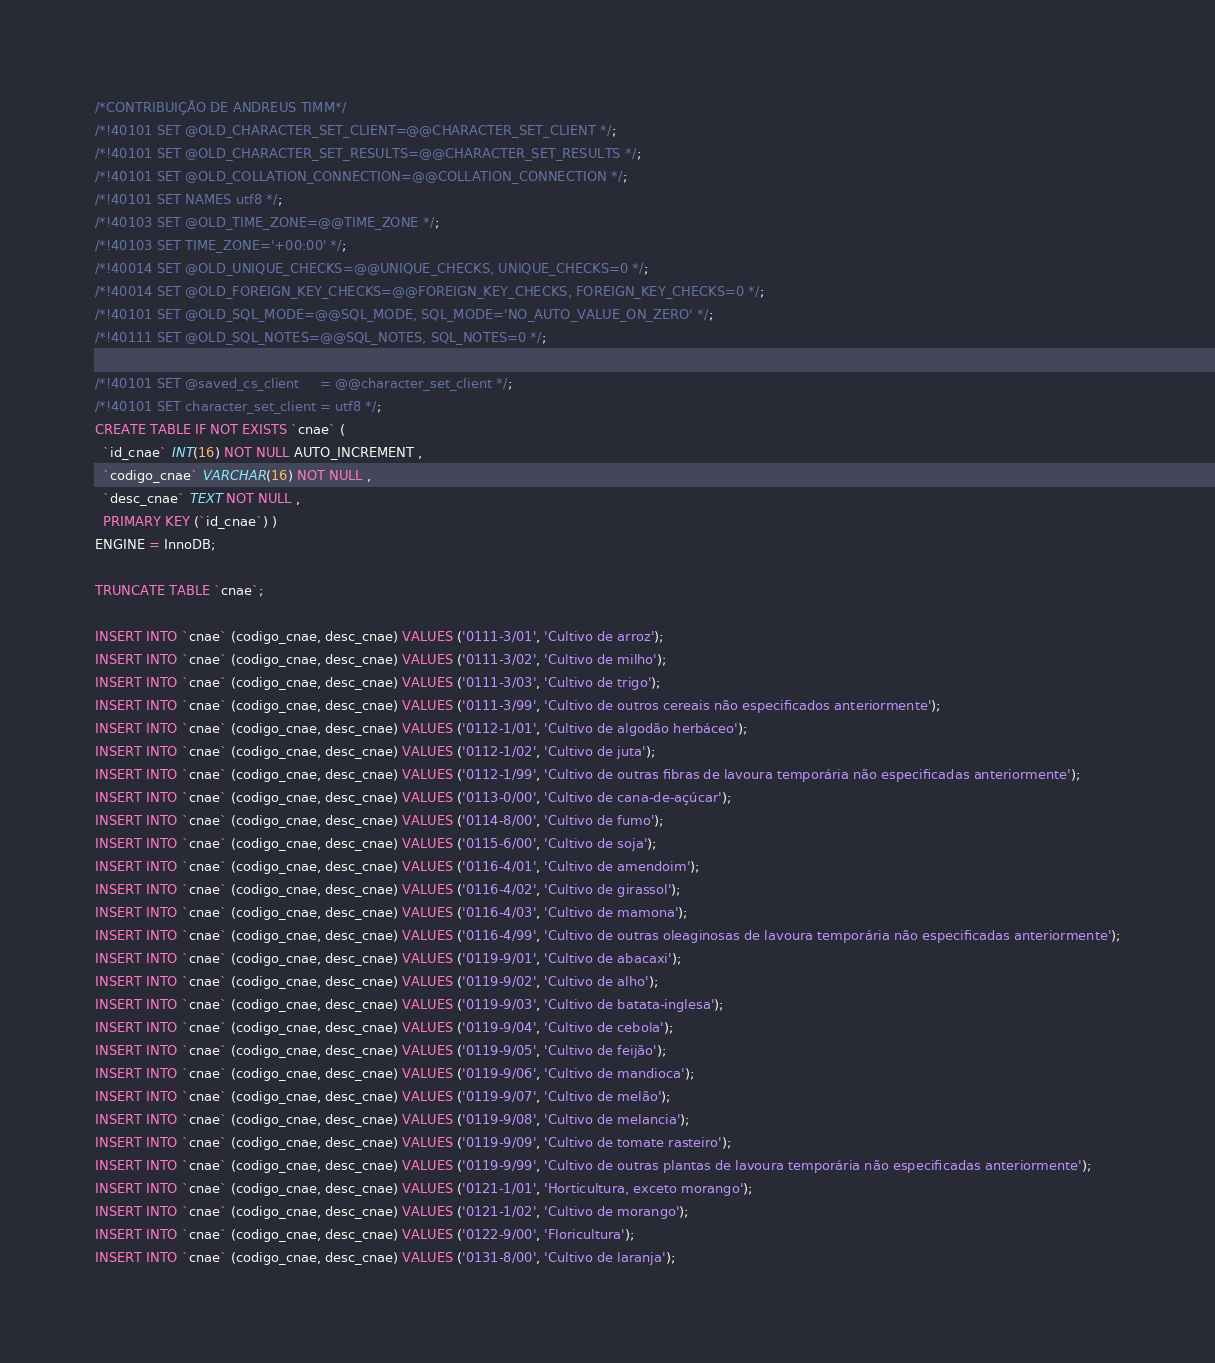Convert code to text. <code><loc_0><loc_0><loc_500><loc_500><_SQL_>/*CONTRIBUIÇÃO DE ANDREUS TIMM*/
/*!40101 SET @OLD_CHARACTER_SET_CLIENT=@@CHARACTER_SET_CLIENT */;
/*!40101 SET @OLD_CHARACTER_SET_RESULTS=@@CHARACTER_SET_RESULTS */;
/*!40101 SET @OLD_COLLATION_CONNECTION=@@COLLATION_CONNECTION */;
/*!40101 SET NAMES utf8 */;
/*!40103 SET @OLD_TIME_ZONE=@@TIME_ZONE */;
/*!40103 SET TIME_ZONE='+00:00' */;
/*!40014 SET @OLD_UNIQUE_CHECKS=@@UNIQUE_CHECKS, UNIQUE_CHECKS=0 */;
/*!40014 SET @OLD_FOREIGN_KEY_CHECKS=@@FOREIGN_KEY_CHECKS, FOREIGN_KEY_CHECKS=0 */;
/*!40101 SET @OLD_SQL_MODE=@@SQL_MODE, SQL_MODE='NO_AUTO_VALUE_ON_ZERO' */;
/*!40111 SET @OLD_SQL_NOTES=@@SQL_NOTES, SQL_NOTES=0 */;

/*!40101 SET @saved_cs_client     = @@character_set_client */;
/*!40101 SET character_set_client = utf8 */;
CREATE TABLE IF NOT EXISTS `cnae` (
  `id_cnae` INT(16) NOT NULL AUTO_INCREMENT ,
  `codigo_cnae` VARCHAR(16) NOT NULL ,
  `desc_cnae` TEXT NOT NULL ,
  PRIMARY KEY (`id_cnae`) )
ENGINE = InnoDB;

TRUNCATE TABLE `cnae`;

INSERT INTO `cnae` (codigo_cnae, desc_cnae) VALUES ('0111-3/01', 'Cultivo de arroz');
INSERT INTO `cnae` (codigo_cnae, desc_cnae) VALUES ('0111-3/02', 'Cultivo de milho');
INSERT INTO `cnae` (codigo_cnae, desc_cnae) VALUES ('0111-3/03', 'Cultivo de trigo');
INSERT INTO `cnae` (codigo_cnae, desc_cnae) VALUES ('0111-3/99', 'Cultivo de outros cereais não especificados anteriormente');
INSERT INTO `cnae` (codigo_cnae, desc_cnae) VALUES ('0112-1/01', 'Cultivo de algodão herbáceo');
INSERT INTO `cnae` (codigo_cnae, desc_cnae) VALUES ('0112-1/02', 'Cultivo de juta');
INSERT INTO `cnae` (codigo_cnae, desc_cnae) VALUES ('0112-1/99', 'Cultivo de outras fibras de lavoura temporária não especificadas anteriormente');
INSERT INTO `cnae` (codigo_cnae, desc_cnae) VALUES ('0113-0/00', 'Cultivo de cana-de-açúcar');
INSERT INTO `cnae` (codigo_cnae, desc_cnae) VALUES ('0114-8/00', 'Cultivo de fumo');
INSERT INTO `cnae` (codigo_cnae, desc_cnae) VALUES ('0115-6/00', 'Cultivo de soja');
INSERT INTO `cnae` (codigo_cnae, desc_cnae) VALUES ('0116-4/01', 'Cultivo de amendoim');
INSERT INTO `cnae` (codigo_cnae, desc_cnae) VALUES ('0116-4/02', 'Cultivo de girassol');
INSERT INTO `cnae` (codigo_cnae, desc_cnae) VALUES ('0116-4/03', 'Cultivo de mamona');
INSERT INTO `cnae` (codigo_cnae, desc_cnae) VALUES ('0116-4/99', 'Cultivo de outras oleaginosas de lavoura temporária não especificadas anteriormente');
INSERT INTO `cnae` (codigo_cnae, desc_cnae) VALUES ('0119-9/01', 'Cultivo de abacaxi');
INSERT INTO `cnae` (codigo_cnae, desc_cnae) VALUES ('0119-9/02', 'Cultivo de alho');
INSERT INTO `cnae` (codigo_cnae, desc_cnae) VALUES ('0119-9/03', 'Cultivo de batata-inglesa');
INSERT INTO `cnae` (codigo_cnae, desc_cnae) VALUES ('0119-9/04', 'Cultivo de cebola');
INSERT INTO `cnae` (codigo_cnae, desc_cnae) VALUES ('0119-9/05', 'Cultivo de feijão');
INSERT INTO `cnae` (codigo_cnae, desc_cnae) VALUES ('0119-9/06', 'Cultivo de mandioca');
INSERT INTO `cnae` (codigo_cnae, desc_cnae) VALUES ('0119-9/07', 'Cultivo de melão');
INSERT INTO `cnae` (codigo_cnae, desc_cnae) VALUES ('0119-9/08', 'Cultivo de melancia');
INSERT INTO `cnae` (codigo_cnae, desc_cnae) VALUES ('0119-9/09', 'Cultivo de tomate rasteiro');
INSERT INTO `cnae` (codigo_cnae, desc_cnae) VALUES ('0119-9/99', 'Cultivo de outras plantas de lavoura temporária não especificadas anteriormente');
INSERT INTO `cnae` (codigo_cnae, desc_cnae) VALUES ('0121-1/01', 'Horticultura, exceto morango');
INSERT INTO `cnae` (codigo_cnae, desc_cnae) VALUES ('0121-1/02', 'Cultivo de morango');
INSERT INTO `cnae` (codigo_cnae, desc_cnae) VALUES ('0122-9/00', 'Floricultura');
INSERT INTO `cnae` (codigo_cnae, desc_cnae) VALUES ('0131-8/00', 'Cultivo de laranja');</code> 